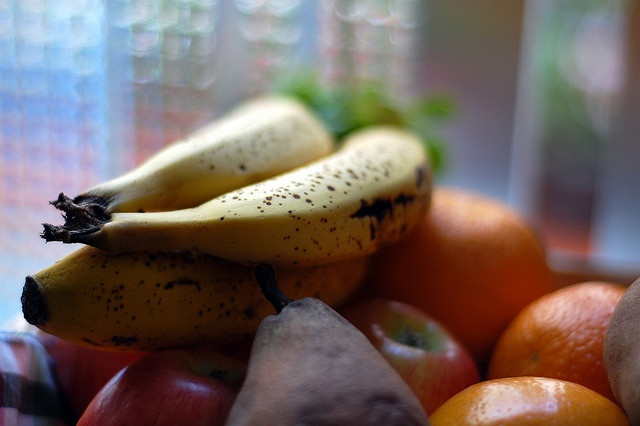Describe the objects in this image and their specific colors. I can see banana in lightblue, black, maroon, ivory, and olive tones, orange in lightblue, maroon, black, and tan tones, apple in lightblue, black, maroon, and purple tones, orange in lightblue, maroon, lightpink, and brown tones, and apple in lightblue, maroon, black, and gray tones in this image. 